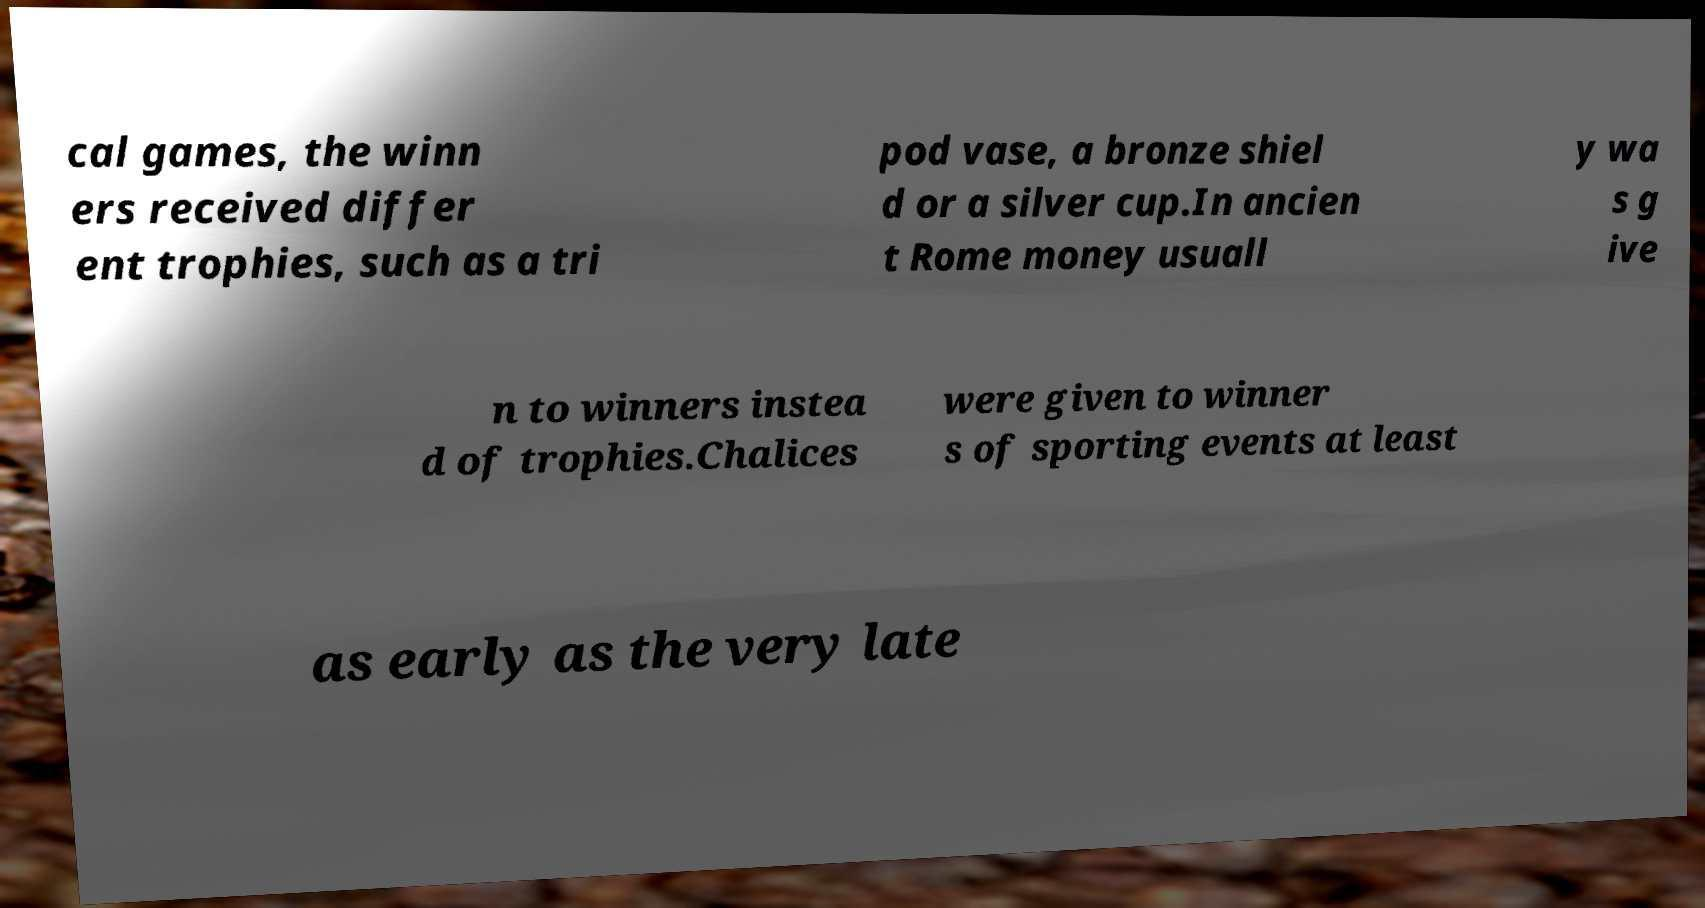Please read and relay the text visible in this image. What does it say? cal games, the winn ers received differ ent trophies, such as a tri pod vase, a bronze shiel d or a silver cup.In ancien t Rome money usuall y wa s g ive n to winners instea d of trophies.Chalices were given to winner s of sporting events at least as early as the very late 